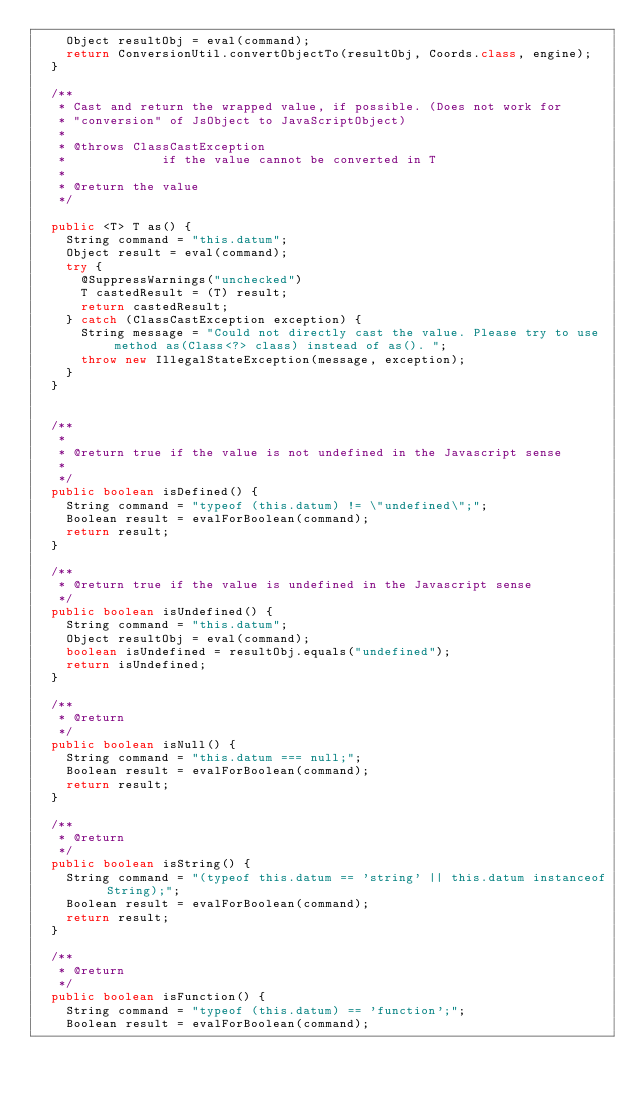<code> <loc_0><loc_0><loc_500><loc_500><_Java_>		Object resultObj = eval(command);
		return ConversionUtil.convertObjectTo(resultObj, Coords.class, engine);
	}

	/**
	 * Cast and return the wrapped value, if possible. (Does not work for
	 * "conversion" of JsObject to JavaScriptObject)
	 *
	 * @throws ClassCastException
	 *             if the value cannot be converted in T
	 *
	 * @return the value
	 */

	public <T> T as() {
		String command = "this.datum";
		Object result = eval(command);
		try {
			@SuppressWarnings("unchecked")
			T castedResult = (T) result;
			return castedResult;
		} catch (ClassCastException exception) {
			String message = "Could not directly cast the value. Please try to use method as(Class<?> class) instead of as(). ";
			throw new IllegalStateException(message, exception);
		}
	}


	/**
	 *
	 * @return true if the value is not undefined in the Javascript sense
	 *
	 */
	public boolean isDefined() {
		String command = "typeof (this.datum) != \"undefined\";";
		Boolean result = evalForBoolean(command);
		return result;
	}

	/**
	 * @return true if the value is undefined in the Javascript sense
	 */
	public boolean isUndefined() {
		String command = "this.datum";
		Object resultObj = eval(command);
		boolean isUndefined = resultObj.equals("undefined");
		return isUndefined;
	}

	/**
	 * @return
	 */
	public boolean isNull() {
		String command = "this.datum === null;";
		Boolean result = evalForBoolean(command);
		return result;
	}

	/**
	 * @return
	 */
	public boolean isString() {
		String command = "(typeof this.datum == 'string' || this.datum instanceof String);";
		Boolean result = evalForBoolean(command);
		return result;
	}

	/**
	 * @return
	 */
	public boolean isFunction() {
		String command = "typeof (this.datum) == 'function';";
		Boolean result = evalForBoolean(command);</code> 